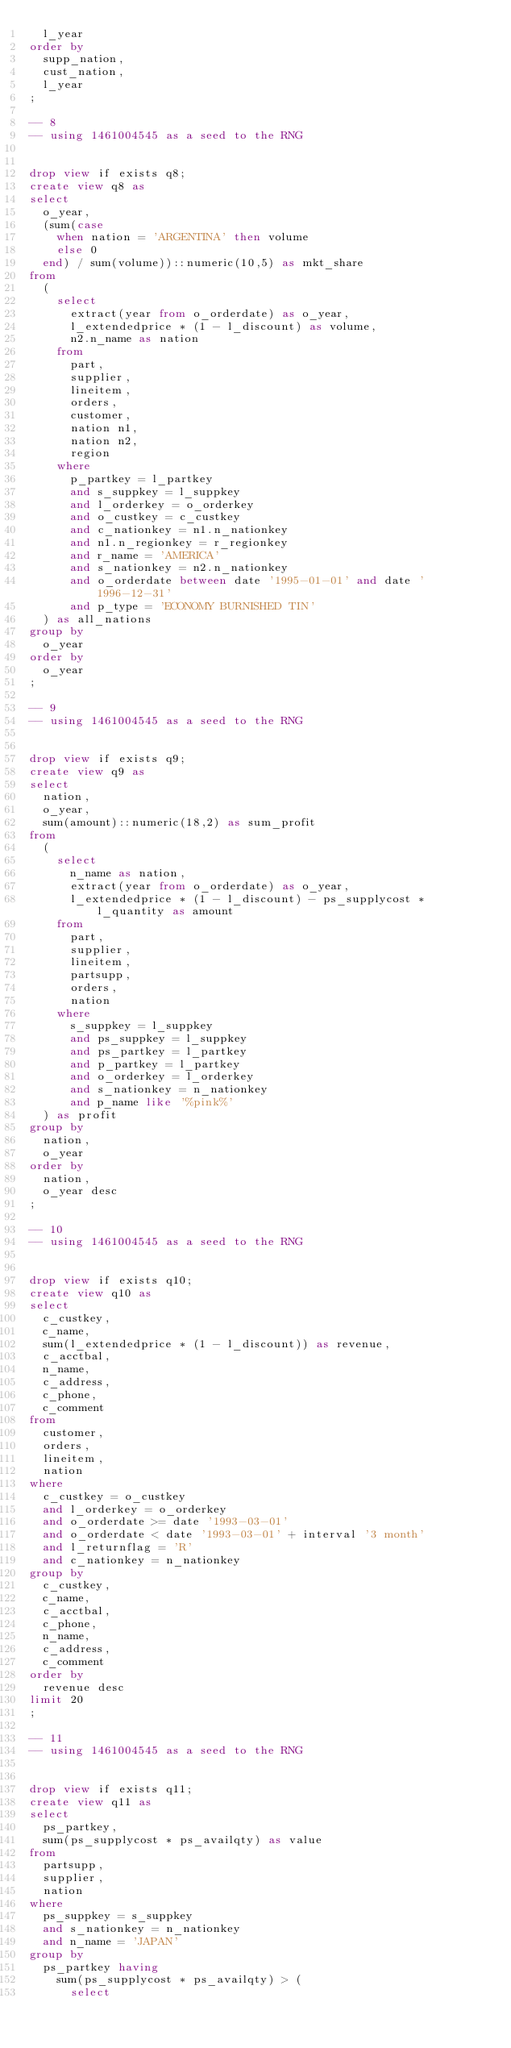Convert code to text. <code><loc_0><loc_0><loc_500><loc_500><_SQL_>	l_year
order by
	supp_nation,
	cust_nation,
	l_year
;

-- 8
-- using 1461004545 as a seed to the RNG


drop view if exists q8;
create view q8 as
select
	o_year,
	(sum(case
		when nation = 'ARGENTINA' then volume
		else 0
	end) / sum(volume))::numeric(10,5) as mkt_share
from
	(
		select
			extract(year from o_orderdate) as o_year,
			l_extendedprice * (1 - l_discount) as volume,
			n2.n_name as nation
		from
			part,
			supplier,
			lineitem,
			orders,
			customer,
			nation n1,
			nation n2,
			region
		where
			p_partkey = l_partkey
			and s_suppkey = l_suppkey
			and l_orderkey = o_orderkey
			and o_custkey = c_custkey
			and c_nationkey = n1.n_nationkey
			and n1.n_regionkey = r_regionkey
			and r_name = 'AMERICA'
			and s_nationkey = n2.n_nationkey
			and o_orderdate between date '1995-01-01' and date '1996-12-31'
			and p_type = 'ECONOMY BURNISHED TIN'
	) as all_nations
group by
	o_year
order by
	o_year
;

-- 9
-- using 1461004545 as a seed to the RNG


drop view if exists q9;
create view q9 as
select
	nation,
	o_year,
	sum(amount)::numeric(18,2) as sum_profit
from
	(
		select
			n_name as nation,
			extract(year from o_orderdate) as o_year,
			l_extendedprice * (1 - l_discount) - ps_supplycost * l_quantity as amount
		from
			part,
			supplier,
			lineitem,
			partsupp,
			orders,
			nation
		where
			s_suppkey = l_suppkey
			and ps_suppkey = l_suppkey
			and ps_partkey = l_partkey
			and p_partkey = l_partkey
			and o_orderkey = l_orderkey
			and s_nationkey = n_nationkey
			and p_name like '%pink%'
	) as profit
group by
	nation,
	o_year
order by
	nation,
	o_year desc
;

-- 10
-- using 1461004545 as a seed to the RNG


drop view if exists q10;
create view q10 as
select
	c_custkey,
	c_name,
	sum(l_extendedprice * (1 - l_discount)) as revenue,
	c_acctbal,
	n_name,
	c_address,
	c_phone,
	c_comment
from
	customer,
	orders,
	lineitem,
	nation
where
	c_custkey = o_custkey
	and l_orderkey = o_orderkey
	and o_orderdate >= date '1993-03-01'
	and o_orderdate < date '1993-03-01' + interval '3 month'
	and l_returnflag = 'R'
	and c_nationkey = n_nationkey
group by
	c_custkey,
	c_name,
	c_acctbal,
	c_phone,
	n_name,
	c_address,
	c_comment
order by
	revenue desc
limit 20
;

-- 11
-- using 1461004545 as a seed to the RNG


drop view if exists q11;
create view q11 as
select
	ps_partkey,
	sum(ps_supplycost * ps_availqty) as value
from
	partsupp,
	supplier,
	nation
where
	ps_suppkey = s_suppkey
	and s_nationkey = n_nationkey
	and n_name = 'JAPAN'
group by
	ps_partkey having
		sum(ps_supplycost * ps_availqty) > (
			select</code> 